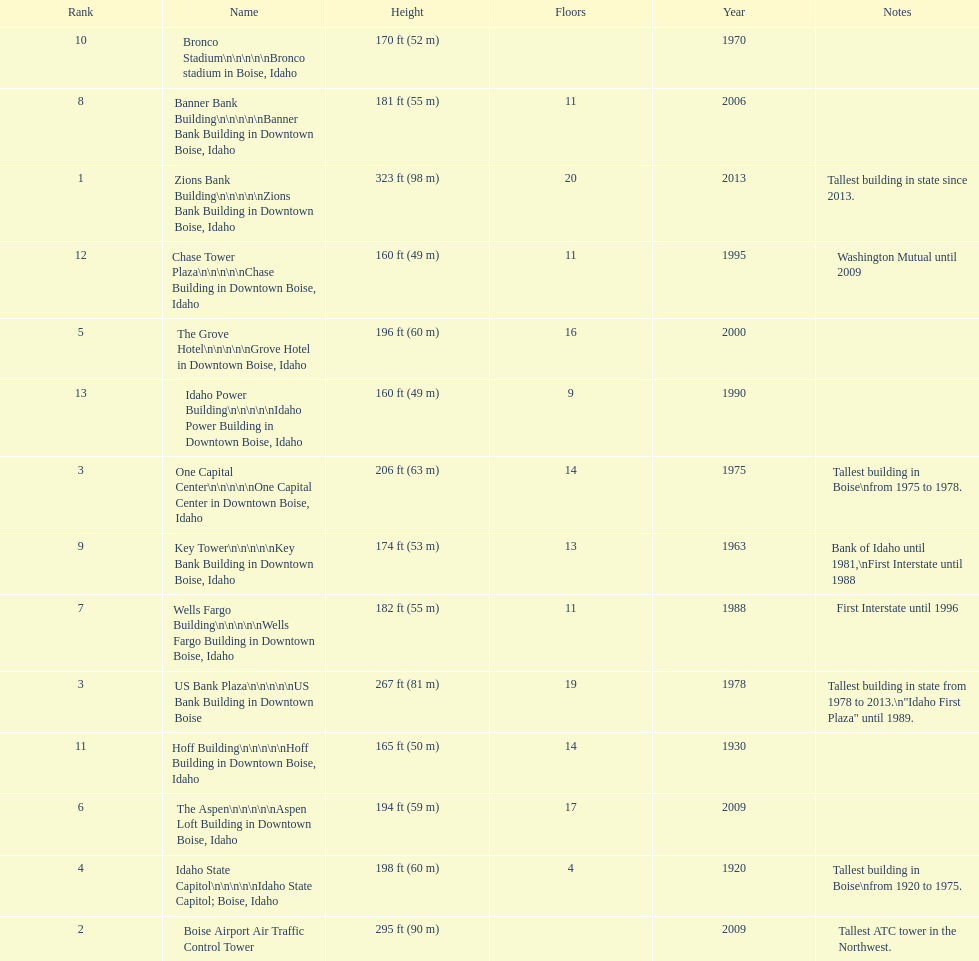What is the name of the building listed after idaho state capitol? The Grove Hotel. 